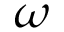Convert formula to latex. <formula><loc_0><loc_0><loc_500><loc_500>\omega</formula> 